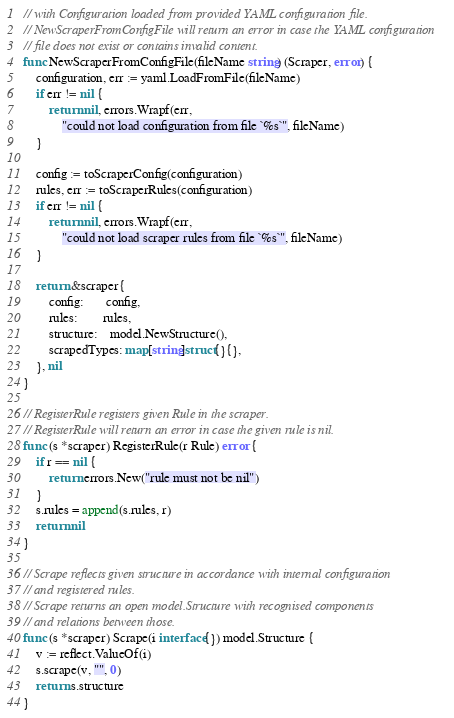Convert code to text. <code><loc_0><loc_0><loc_500><loc_500><_Go_>// with Configuration loaded from provided YAML configuration file.
// NewScraperFromConfigFile will return an error in case the YAML configuration
// file does not exist or contains invalid content.
func NewScraperFromConfigFile(fileName string) (Scraper, error) {
	configuration, err := yaml.LoadFromFile(fileName)
	if err != nil {
		return nil, errors.Wrapf(err,
			"could not load configuration from file `%s`", fileName)
	}

	config := toScraperConfig(configuration)
	rules, err := toScraperRules(configuration)
	if err != nil {
		return nil, errors.Wrapf(err,
			"could not load scraper rules from file `%s`", fileName)
	}

	return &scraper{
		config:       config,
		rules:        rules,
		structure:    model.NewStructure(),
		scrapedTypes: map[string]struct{}{},
	}, nil
}

// RegisterRule registers given Rule in the scraper.
// RegisterRule will return an error in case the given rule is nil.
func (s *scraper) RegisterRule(r Rule) error {
	if r == nil {
		return errors.New("rule must not be nil")
	}
	s.rules = append(s.rules, r)
	return nil
}

// Scrape reflects given structure in accordance with internal configuration
// and registered rules.
// Scrape returns an open model.Structure with recognised components
// and relations between those.
func (s *scraper) Scrape(i interface{}) model.Structure {
	v := reflect.ValueOf(i)
	s.scrape(v, "", 0)
	return s.structure
}
</code> 